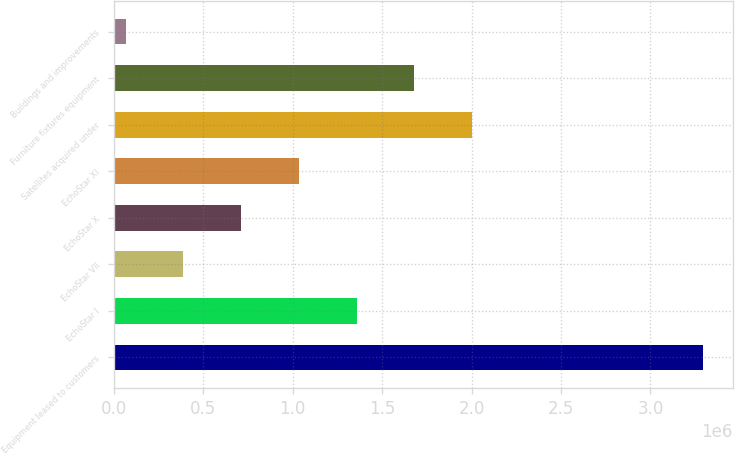Convert chart. <chart><loc_0><loc_0><loc_500><loc_500><bar_chart><fcel>Equipment leased to customers<fcel>EchoStar I<fcel>EchoStar VII<fcel>EchoStar X<fcel>EchoStar XI<fcel>Satellites acquired under<fcel>Furniture fixtures equipment<fcel>Buildings and improvements<nl><fcel>3.2953e+06<fcel>1.35809e+06<fcel>389481<fcel>712349<fcel>1.03522e+06<fcel>2.00382e+06<fcel>1.68096e+06<fcel>66612<nl></chart> 